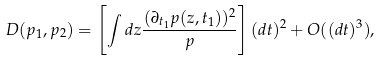<formula> <loc_0><loc_0><loc_500><loc_500>D ( p _ { 1 } , p _ { 2 } ) = \left [ \int d z \frac { ( \partial _ { t _ { 1 } } p ( z , t _ { 1 } ) ) ^ { 2 } } { p } \right ] ( d t ) ^ { 2 } + O ( ( d t ) ^ { 3 } ) ,</formula> 